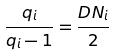<formula> <loc_0><loc_0><loc_500><loc_500>\frac { q _ { i } } { q _ { i } - 1 } = \frac { D N _ { i } } { 2 }</formula> 